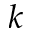<formula> <loc_0><loc_0><loc_500><loc_500>k</formula> 